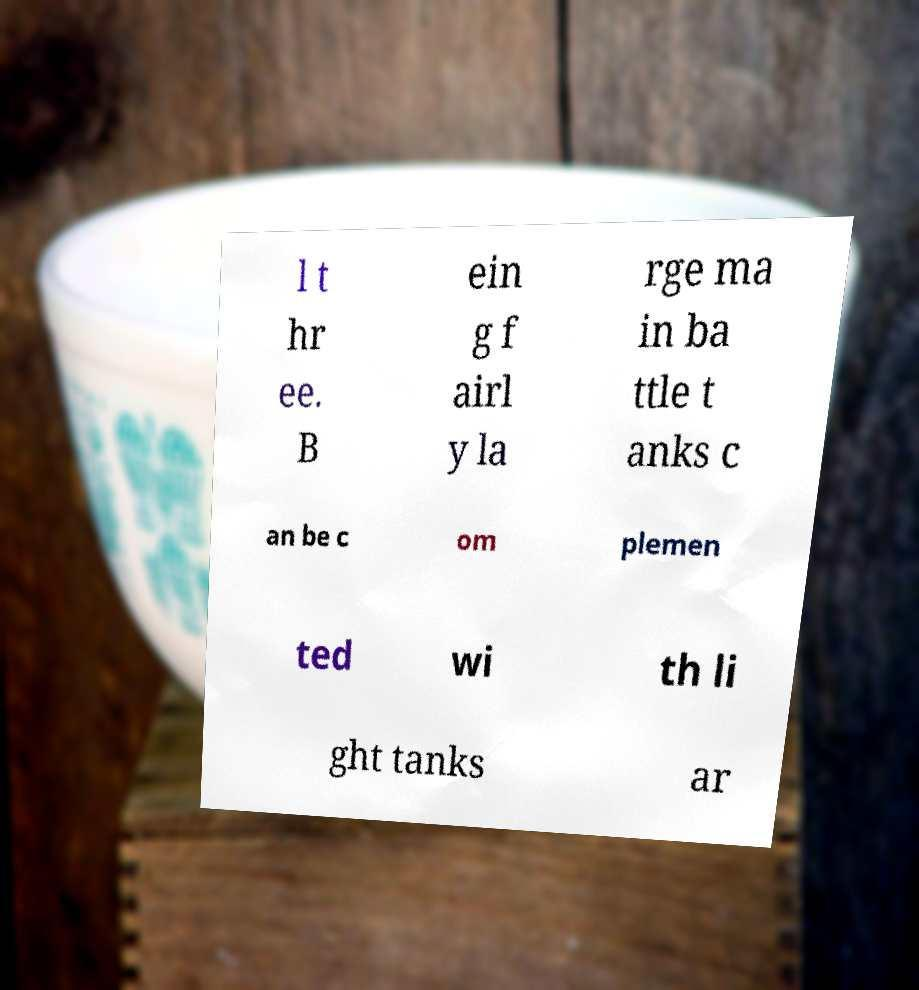Could you extract and type out the text from this image? l t hr ee. B ein g f airl y la rge ma in ba ttle t anks c an be c om plemen ted wi th li ght tanks ar 